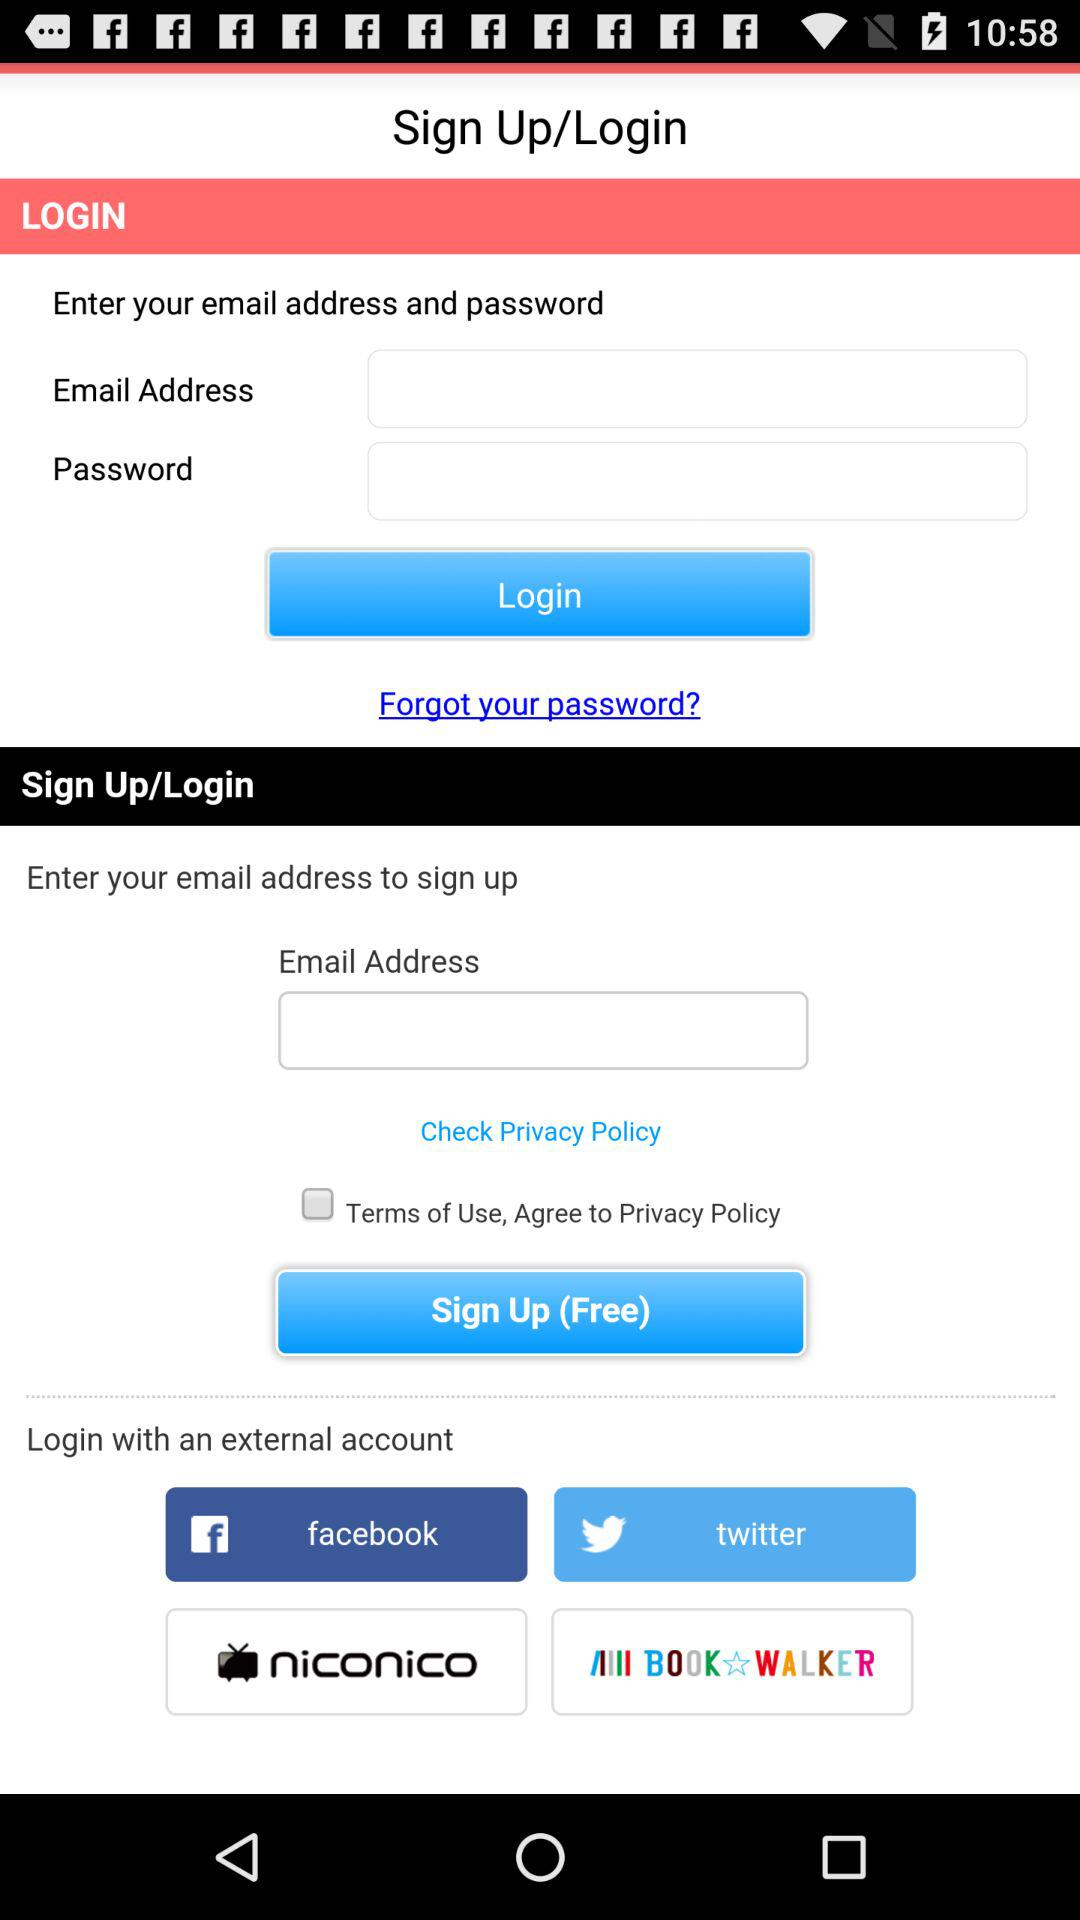Which application can be used to sign up? The applications "facebook", "twitter", "niconico" and "BOOK WALKER - Manga & Novels" can be used to sign up. 